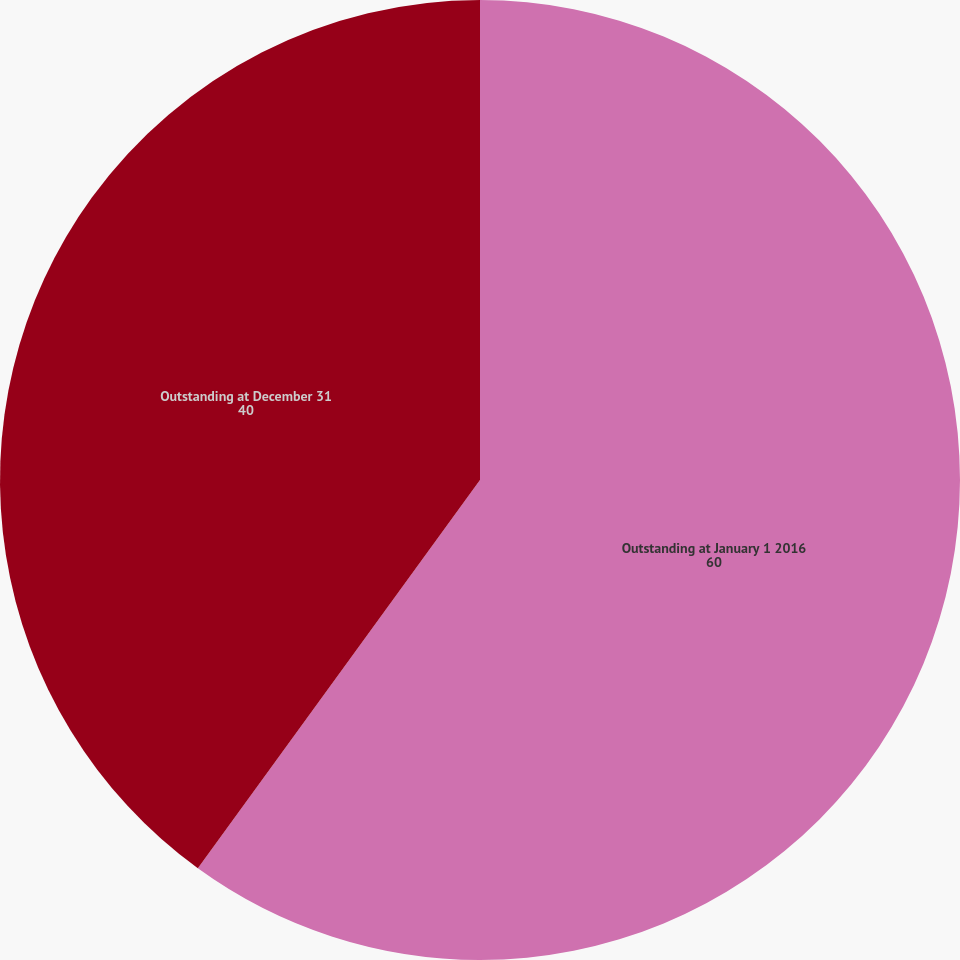<chart> <loc_0><loc_0><loc_500><loc_500><pie_chart><fcel>Outstanding at January 1 2016<fcel>Outstanding at December 31<nl><fcel>60.0%<fcel>40.0%<nl></chart> 